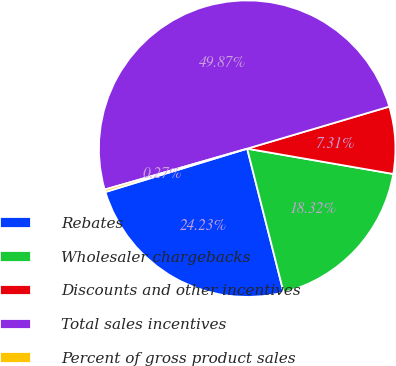Convert chart to OTSL. <chart><loc_0><loc_0><loc_500><loc_500><pie_chart><fcel>Rebates<fcel>Wholesaler chargebacks<fcel>Discounts and other incentives<fcel>Total sales incentives<fcel>Percent of gross product sales<nl><fcel>24.23%<fcel>18.32%<fcel>7.31%<fcel>49.87%<fcel>0.27%<nl></chart> 